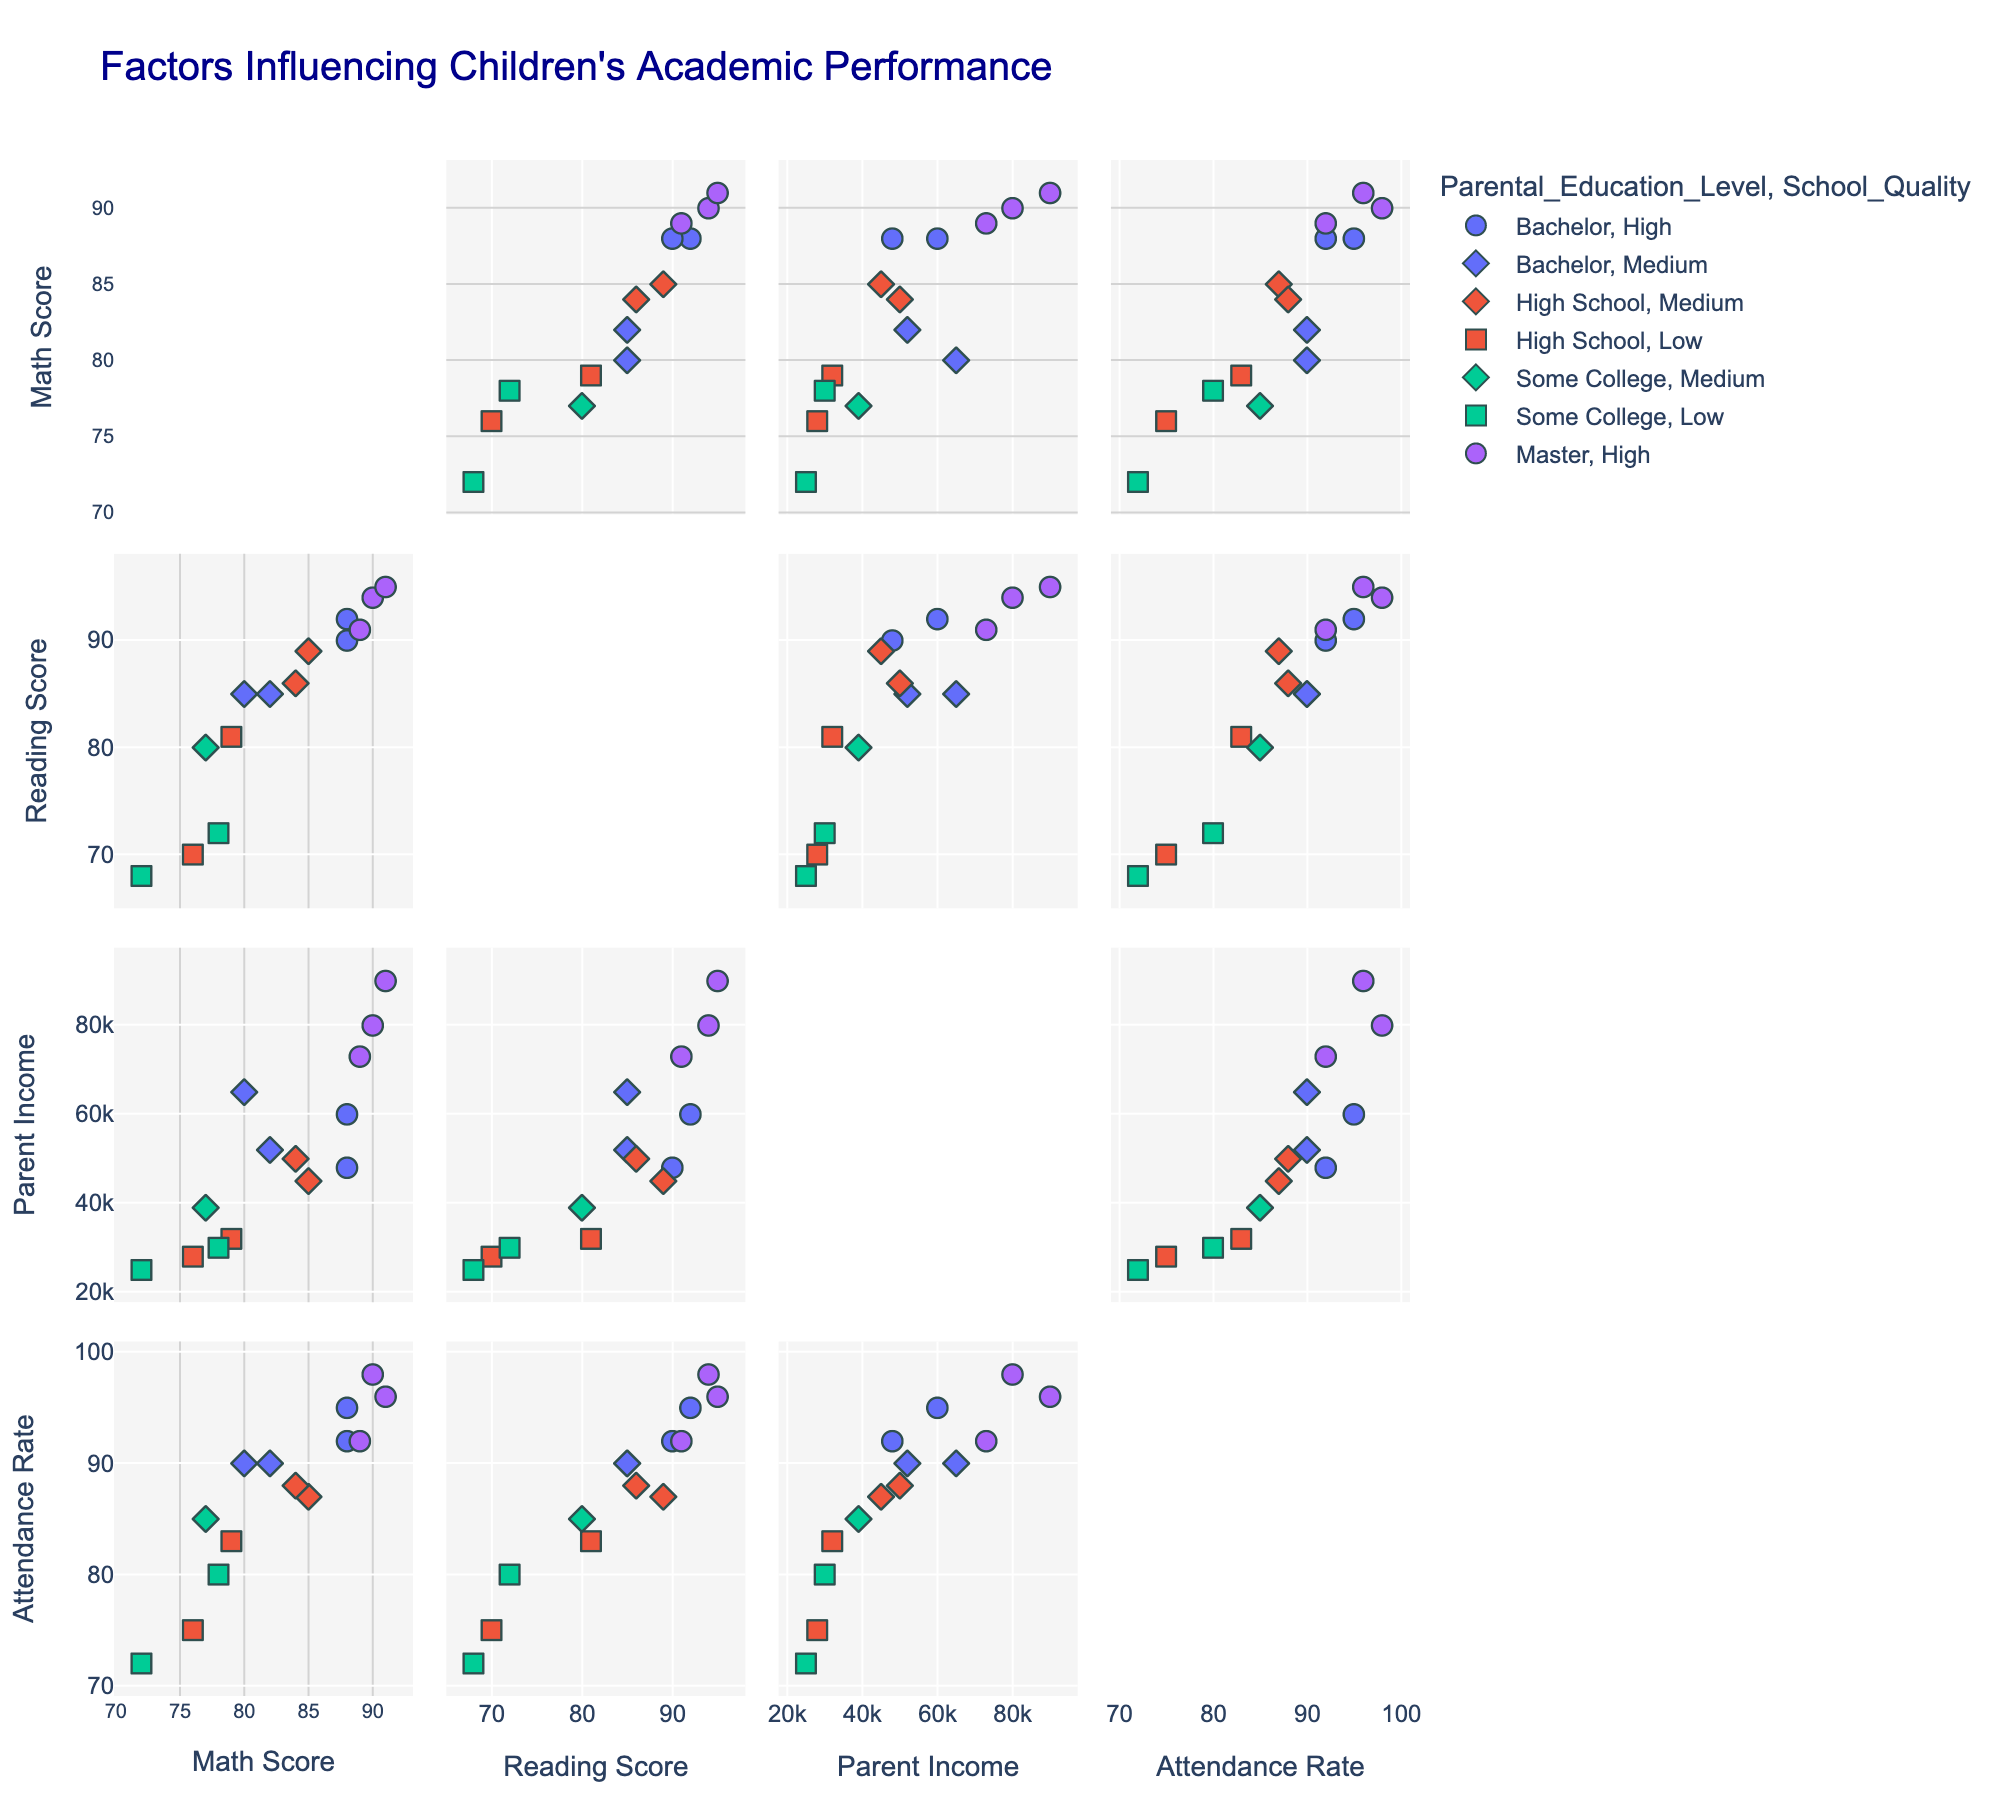What is the title of the figure? The title is typically centered at the top of the plot. It gives an indication of what the entire plot is about.
Answer: Factors Influencing Children's Academic Performance Which parental education level is represented in green? The SPLOM uses colors to differentiate data points based on their categorical variables. The legend usually indicates which color corresponds to which category.
Answer: Bachelor How does Math Score correlate with Parent Income? By looking at the scatter plot between Math Score and Parent Income, one can observe the general trend of the data points.
Answer: Positively correlated Which School Quality symbol has the highest average Math Score? Symbols in SPLOM represent categorical variables like School Quality. To find the highest average, compute the average Math Score for each symbol.
Answer: High Compare the Math Scores of children whose parents have a Master's degree to those with a High School education level. By filtering the data points based on Parental Education Level using the legend, one can compare the spread and average scores of each group.
Answer: Master's degree children have higher Math Scores on average Which Parental Education Level group has the most data points? By examining the density of data points for each color coded in the legend representing Parental Education Levels, the most populous group can be identified.
Answer: High School What relationship can be observed between Attendance Rate and Reading Score? By examining the specific scatter plot that plots these two variables against each other, a visible pattern or trend can be observed.
Answer: Positively correlated Are children from neighborhoods with high safety more likely to have higher Attendance Rates? By using the hover data, which includes Neighborhood Safety, one can analyze the Attendance Rates associated with different safety levels.
Answer: Yes Which combination of variables shows the least correlation? By visually inspecting all scatter plots, one can identify which combination has data points that are scattered without a clear pattern.
Answer: Parent Income and Attendance Rate Identify one outlier in the Math Score vs. Reading Score scatter plot. Outliers can be identified as points that are far from the main cluster of data points in the scatter plot.
Answer: One outlier is John with Math Score 88 and Reading Score 92 